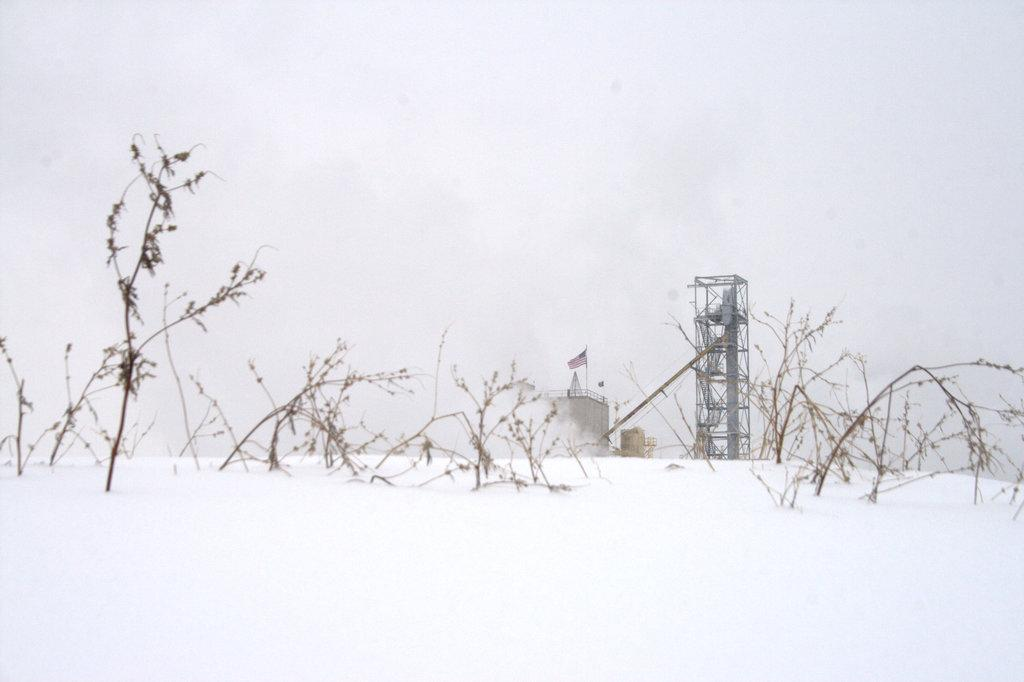What structure is located on the right side of the image? There is a tower on the right side of the image. What other building can be seen in the image? There is a building with a flag in the image. What is present at the bottom of the image? There are plants and snow at the bottom of the image. What can be seen in the background of the image? The sky is visible in the background of the image. What type of horn is visible on the side of the building in the image? There is no horn present on the side of the building in the image. How much money is being exchanged in the image? There is no exchange of money depicted in the image. 